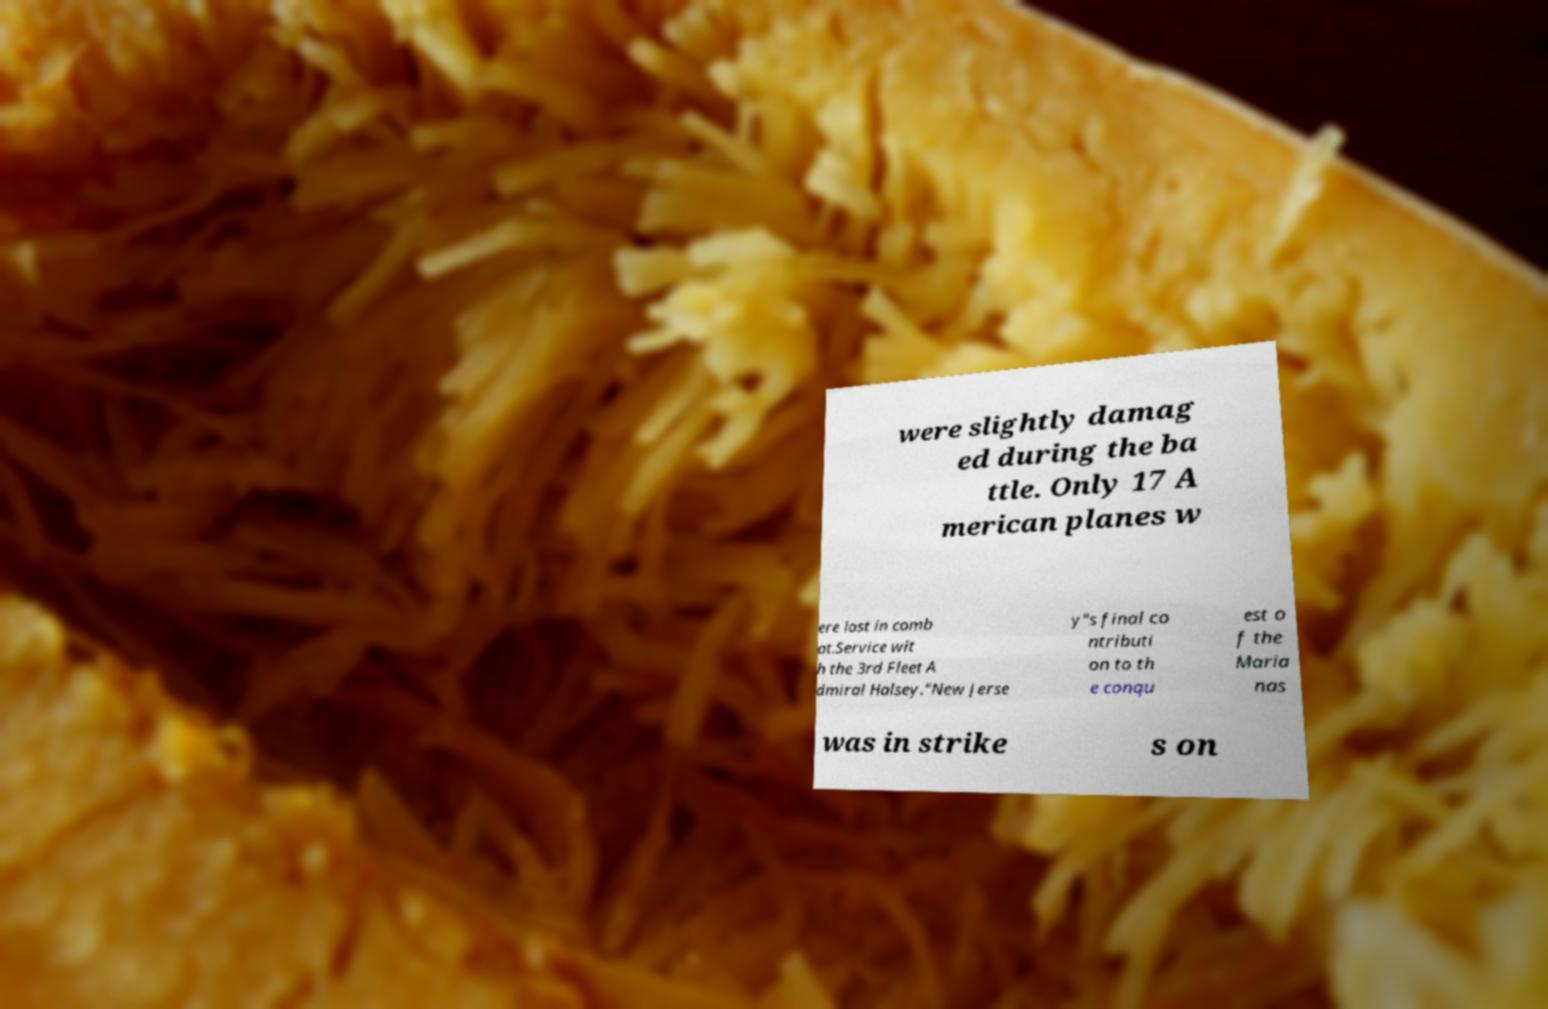Please read and relay the text visible in this image. What does it say? were slightly damag ed during the ba ttle. Only 17 A merican planes w ere lost in comb at.Service wit h the 3rd Fleet A dmiral Halsey."New Jerse y"s final co ntributi on to th e conqu est o f the Maria nas was in strike s on 